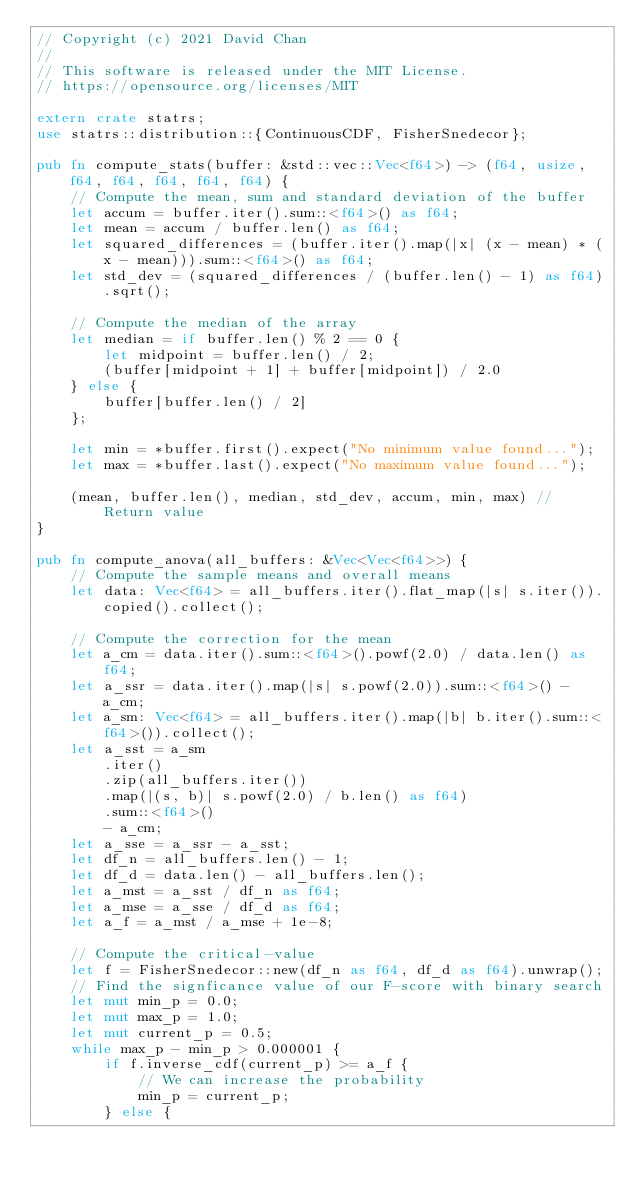<code> <loc_0><loc_0><loc_500><loc_500><_Rust_>// Copyright (c) 2021 David Chan
//
// This software is released under the MIT License.
// https://opensource.org/licenses/MIT

extern crate statrs;
use statrs::distribution::{ContinuousCDF, FisherSnedecor};

pub fn compute_stats(buffer: &std::vec::Vec<f64>) -> (f64, usize, f64, f64, f64, f64, f64) {
    // Compute the mean, sum and standard deviation of the buffer
    let accum = buffer.iter().sum::<f64>() as f64;
    let mean = accum / buffer.len() as f64;
    let squared_differences = (buffer.iter().map(|x| (x - mean) * (x - mean))).sum::<f64>() as f64;
    let std_dev = (squared_differences / (buffer.len() - 1) as f64).sqrt();

    // Compute the median of the array
    let median = if buffer.len() % 2 == 0 {
        let midpoint = buffer.len() / 2;
        (buffer[midpoint + 1] + buffer[midpoint]) / 2.0
    } else {
        buffer[buffer.len() / 2]
    };

    let min = *buffer.first().expect("No minimum value found...");
    let max = *buffer.last().expect("No maximum value found...");

    (mean, buffer.len(), median, std_dev, accum, min, max) // Return value
}

pub fn compute_anova(all_buffers: &Vec<Vec<f64>>) {
    // Compute the sample means and overall means
    let data: Vec<f64> = all_buffers.iter().flat_map(|s| s.iter()).copied().collect();

    // Compute the correction for the mean
    let a_cm = data.iter().sum::<f64>().powf(2.0) / data.len() as f64;
    let a_ssr = data.iter().map(|s| s.powf(2.0)).sum::<f64>() - a_cm;
    let a_sm: Vec<f64> = all_buffers.iter().map(|b| b.iter().sum::<f64>()).collect();
    let a_sst = a_sm
        .iter()
        .zip(all_buffers.iter())
        .map(|(s, b)| s.powf(2.0) / b.len() as f64)
        .sum::<f64>()
        - a_cm;
    let a_sse = a_ssr - a_sst;
    let df_n = all_buffers.len() - 1;
    let df_d = data.len() - all_buffers.len();
    let a_mst = a_sst / df_n as f64;
    let a_mse = a_sse / df_d as f64;
    let a_f = a_mst / a_mse + 1e-8;

    // Compute the critical-value
    let f = FisherSnedecor::new(df_n as f64, df_d as f64).unwrap();
    // Find the signficance value of our F-score with binary search
    let mut min_p = 0.0;
    let mut max_p = 1.0;
    let mut current_p = 0.5;
    while max_p - min_p > 0.000001 {
        if f.inverse_cdf(current_p) >= a_f {
            // We can increase the probability
            min_p = current_p;
        } else {</code> 